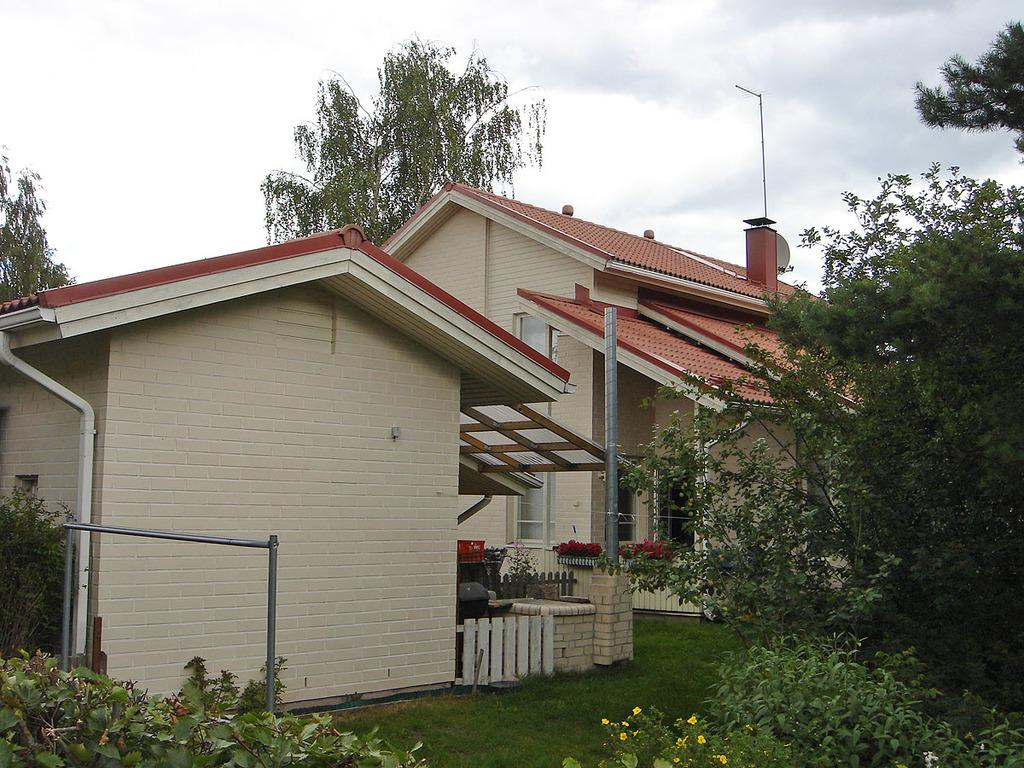What type of structures can be seen in the image? There are houses in the image. What is the purpose of the barrier in the image? There is a fence in the image, which serves as a barrier. What material is present in the image that is commonly used for kitchen appliances and cookware? There is stainless steel in the image. What type of vegetation can be seen in the image? There are plants and trees in the image. What are the tall, slender objects in the image used for? There are poles in the image, which are likely used for support or as markers. What part of the natural environment is visible in the image? The sky is visible in the image. How many bears can be seen climbing the poles in the image? There are no bears present in the image; it features houses, a fence, stainless steel, plants, trees, poles, and a visible sky. What type of metal is used to make the roof of the houses in the image? The provided facts do not mention the material used for the roofs of the houses, so we cannot determine if copper is used. 